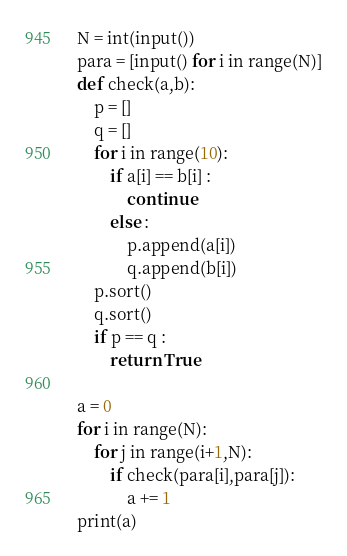<code> <loc_0><loc_0><loc_500><loc_500><_Python_>N = int(input())
para = [input() for i in range(N)]
def check(a,b):
    p = []
    q = []
    for i in range(10):
        if a[i] == b[i] :
            continue
        else :
            p.append(a[i])
            q.append(b[i])
    p.sort()
    q.sort()
    if p == q :
        return True 
            
a = 0 
for i in range(N):
    for j in range(i+1,N):
        if check(para[i],para[j]):
            a += 1
print(a)
</code> 